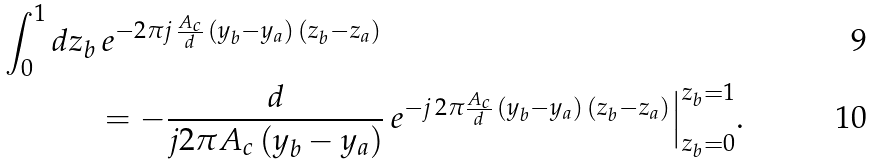Convert formula to latex. <formula><loc_0><loc_0><loc_500><loc_500>\int _ { 0 } ^ { 1 } d z _ { b } & \, e ^ { - 2 \pi j \, \frac { A _ { c } } { d } \, ( y _ { b } - y _ { a } ) \, ( z _ { b } - z _ { a } ) } \\ & = - \frac { d } { j 2 \pi A _ { c } \, ( y _ { b } - y _ { a } ) } \, e ^ { - j \, 2 \pi \frac { A _ { c } } { d } \, ( y _ { b } - y _ { a } ) \, ( z _ { b } - z _ { a } ) } \Big | _ { z _ { b } = 0 } ^ { z _ { b } = 1 } .</formula> 